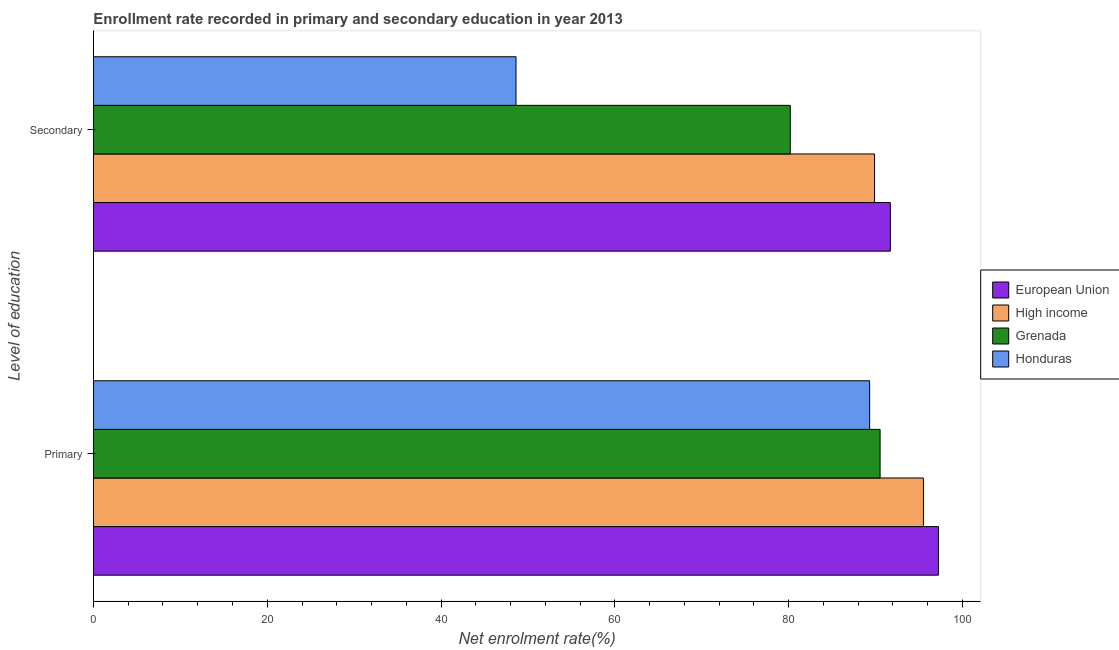How many groups of bars are there?
Offer a very short reply. 2. How many bars are there on the 1st tick from the bottom?
Give a very brief answer. 4. What is the label of the 1st group of bars from the top?
Keep it short and to the point. Secondary. What is the enrollment rate in secondary education in Honduras?
Keep it short and to the point. 48.63. Across all countries, what is the maximum enrollment rate in secondary education?
Ensure brevity in your answer.  91.72. Across all countries, what is the minimum enrollment rate in primary education?
Offer a very short reply. 89.33. In which country was the enrollment rate in primary education minimum?
Provide a short and direct response. Honduras. What is the total enrollment rate in secondary education in the graph?
Offer a terse response. 310.45. What is the difference between the enrollment rate in secondary education in Grenada and that in European Union?
Keep it short and to the point. -11.52. What is the difference between the enrollment rate in primary education in High income and the enrollment rate in secondary education in Honduras?
Give a very brief answer. 46.89. What is the average enrollment rate in primary education per country?
Your response must be concise. 93.16. What is the difference between the enrollment rate in primary education and enrollment rate in secondary education in Honduras?
Your response must be concise. 40.7. In how many countries, is the enrollment rate in secondary education greater than 60 %?
Your answer should be compact. 3. What is the ratio of the enrollment rate in primary education in Honduras to that in High income?
Offer a very short reply. 0.94. In how many countries, is the enrollment rate in secondary education greater than the average enrollment rate in secondary education taken over all countries?
Give a very brief answer. 3. What does the 3rd bar from the top in Secondary represents?
Your answer should be compact. High income. How many bars are there?
Your answer should be very brief. 8. How many countries are there in the graph?
Ensure brevity in your answer.  4. What is the difference between two consecutive major ticks on the X-axis?
Ensure brevity in your answer.  20. Where does the legend appear in the graph?
Your answer should be very brief. Center right. How many legend labels are there?
Your answer should be compact. 4. How are the legend labels stacked?
Offer a very short reply. Vertical. What is the title of the graph?
Make the answer very short. Enrollment rate recorded in primary and secondary education in year 2013. Does "Hong Kong" appear as one of the legend labels in the graph?
Your answer should be compact. No. What is the label or title of the X-axis?
Keep it short and to the point. Net enrolment rate(%). What is the label or title of the Y-axis?
Your response must be concise. Level of education. What is the Net enrolment rate(%) of European Union in Primary?
Your answer should be compact. 97.25. What is the Net enrolment rate(%) in High income in Primary?
Keep it short and to the point. 95.52. What is the Net enrolment rate(%) in Grenada in Primary?
Offer a terse response. 90.54. What is the Net enrolment rate(%) of Honduras in Primary?
Ensure brevity in your answer.  89.33. What is the Net enrolment rate(%) in European Union in Secondary?
Your answer should be compact. 91.72. What is the Net enrolment rate(%) of High income in Secondary?
Keep it short and to the point. 89.9. What is the Net enrolment rate(%) of Grenada in Secondary?
Provide a short and direct response. 80.2. What is the Net enrolment rate(%) in Honduras in Secondary?
Give a very brief answer. 48.63. Across all Level of education, what is the maximum Net enrolment rate(%) in European Union?
Give a very brief answer. 97.25. Across all Level of education, what is the maximum Net enrolment rate(%) of High income?
Provide a short and direct response. 95.52. Across all Level of education, what is the maximum Net enrolment rate(%) of Grenada?
Your answer should be compact. 90.54. Across all Level of education, what is the maximum Net enrolment rate(%) of Honduras?
Offer a terse response. 89.33. Across all Level of education, what is the minimum Net enrolment rate(%) of European Union?
Your answer should be compact. 91.72. Across all Level of education, what is the minimum Net enrolment rate(%) in High income?
Make the answer very short. 89.9. Across all Level of education, what is the minimum Net enrolment rate(%) in Grenada?
Your response must be concise. 80.2. Across all Level of education, what is the minimum Net enrolment rate(%) of Honduras?
Your response must be concise. 48.63. What is the total Net enrolment rate(%) of European Union in the graph?
Provide a succinct answer. 188.97. What is the total Net enrolment rate(%) in High income in the graph?
Make the answer very short. 185.42. What is the total Net enrolment rate(%) of Grenada in the graph?
Your response must be concise. 170.74. What is the total Net enrolment rate(%) of Honduras in the graph?
Make the answer very short. 137.96. What is the difference between the Net enrolment rate(%) in European Union in Primary and that in Secondary?
Your response must be concise. 5.53. What is the difference between the Net enrolment rate(%) in High income in Primary and that in Secondary?
Provide a succinct answer. 5.63. What is the difference between the Net enrolment rate(%) of Grenada in Primary and that in Secondary?
Provide a short and direct response. 10.34. What is the difference between the Net enrolment rate(%) in Honduras in Primary and that in Secondary?
Ensure brevity in your answer.  40.7. What is the difference between the Net enrolment rate(%) of European Union in Primary and the Net enrolment rate(%) of High income in Secondary?
Provide a short and direct response. 7.35. What is the difference between the Net enrolment rate(%) in European Union in Primary and the Net enrolment rate(%) in Grenada in Secondary?
Provide a succinct answer. 17.05. What is the difference between the Net enrolment rate(%) in European Union in Primary and the Net enrolment rate(%) in Honduras in Secondary?
Provide a succinct answer. 48.62. What is the difference between the Net enrolment rate(%) of High income in Primary and the Net enrolment rate(%) of Grenada in Secondary?
Offer a terse response. 15.32. What is the difference between the Net enrolment rate(%) of High income in Primary and the Net enrolment rate(%) of Honduras in Secondary?
Offer a terse response. 46.89. What is the difference between the Net enrolment rate(%) in Grenada in Primary and the Net enrolment rate(%) in Honduras in Secondary?
Make the answer very short. 41.9. What is the average Net enrolment rate(%) of European Union per Level of education?
Provide a succinct answer. 94.48. What is the average Net enrolment rate(%) of High income per Level of education?
Give a very brief answer. 92.71. What is the average Net enrolment rate(%) in Grenada per Level of education?
Make the answer very short. 85.37. What is the average Net enrolment rate(%) in Honduras per Level of education?
Your response must be concise. 68.98. What is the difference between the Net enrolment rate(%) in European Union and Net enrolment rate(%) in High income in Primary?
Ensure brevity in your answer.  1.73. What is the difference between the Net enrolment rate(%) in European Union and Net enrolment rate(%) in Grenada in Primary?
Make the answer very short. 6.71. What is the difference between the Net enrolment rate(%) in European Union and Net enrolment rate(%) in Honduras in Primary?
Your answer should be very brief. 7.92. What is the difference between the Net enrolment rate(%) of High income and Net enrolment rate(%) of Grenada in Primary?
Your response must be concise. 4.99. What is the difference between the Net enrolment rate(%) in High income and Net enrolment rate(%) in Honduras in Primary?
Keep it short and to the point. 6.19. What is the difference between the Net enrolment rate(%) of Grenada and Net enrolment rate(%) of Honduras in Primary?
Your answer should be compact. 1.2. What is the difference between the Net enrolment rate(%) of European Union and Net enrolment rate(%) of High income in Secondary?
Offer a very short reply. 1.82. What is the difference between the Net enrolment rate(%) of European Union and Net enrolment rate(%) of Grenada in Secondary?
Your response must be concise. 11.52. What is the difference between the Net enrolment rate(%) of European Union and Net enrolment rate(%) of Honduras in Secondary?
Give a very brief answer. 43.09. What is the difference between the Net enrolment rate(%) in High income and Net enrolment rate(%) in Grenada in Secondary?
Give a very brief answer. 9.7. What is the difference between the Net enrolment rate(%) in High income and Net enrolment rate(%) in Honduras in Secondary?
Your answer should be very brief. 41.26. What is the difference between the Net enrolment rate(%) in Grenada and Net enrolment rate(%) in Honduras in Secondary?
Your answer should be very brief. 31.57. What is the ratio of the Net enrolment rate(%) of European Union in Primary to that in Secondary?
Your response must be concise. 1.06. What is the ratio of the Net enrolment rate(%) of High income in Primary to that in Secondary?
Offer a terse response. 1.06. What is the ratio of the Net enrolment rate(%) of Grenada in Primary to that in Secondary?
Provide a short and direct response. 1.13. What is the ratio of the Net enrolment rate(%) of Honduras in Primary to that in Secondary?
Offer a terse response. 1.84. What is the difference between the highest and the second highest Net enrolment rate(%) of European Union?
Provide a succinct answer. 5.53. What is the difference between the highest and the second highest Net enrolment rate(%) of High income?
Your answer should be compact. 5.63. What is the difference between the highest and the second highest Net enrolment rate(%) in Grenada?
Make the answer very short. 10.34. What is the difference between the highest and the second highest Net enrolment rate(%) of Honduras?
Offer a terse response. 40.7. What is the difference between the highest and the lowest Net enrolment rate(%) of European Union?
Keep it short and to the point. 5.53. What is the difference between the highest and the lowest Net enrolment rate(%) of High income?
Keep it short and to the point. 5.63. What is the difference between the highest and the lowest Net enrolment rate(%) of Grenada?
Your response must be concise. 10.34. What is the difference between the highest and the lowest Net enrolment rate(%) in Honduras?
Provide a short and direct response. 40.7. 